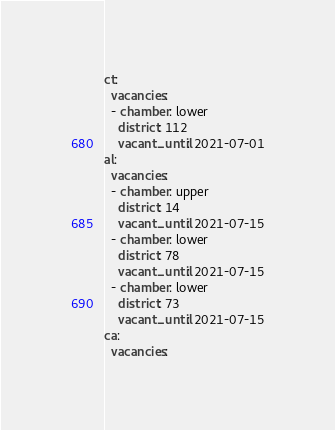Convert code to text. <code><loc_0><loc_0><loc_500><loc_500><_YAML_>ct:
  vacancies:
  - chamber: lower
    district: 112
    vacant_until: 2021-07-01
al:
  vacancies:
  - chamber: upper
    district: 14
    vacant_until: 2021-07-15
  - chamber: lower
    district: 78
    vacant_until: 2021-07-15
  - chamber: lower
    district: 73
    vacant_until: 2021-07-15
ca:
  vacancies:</code> 